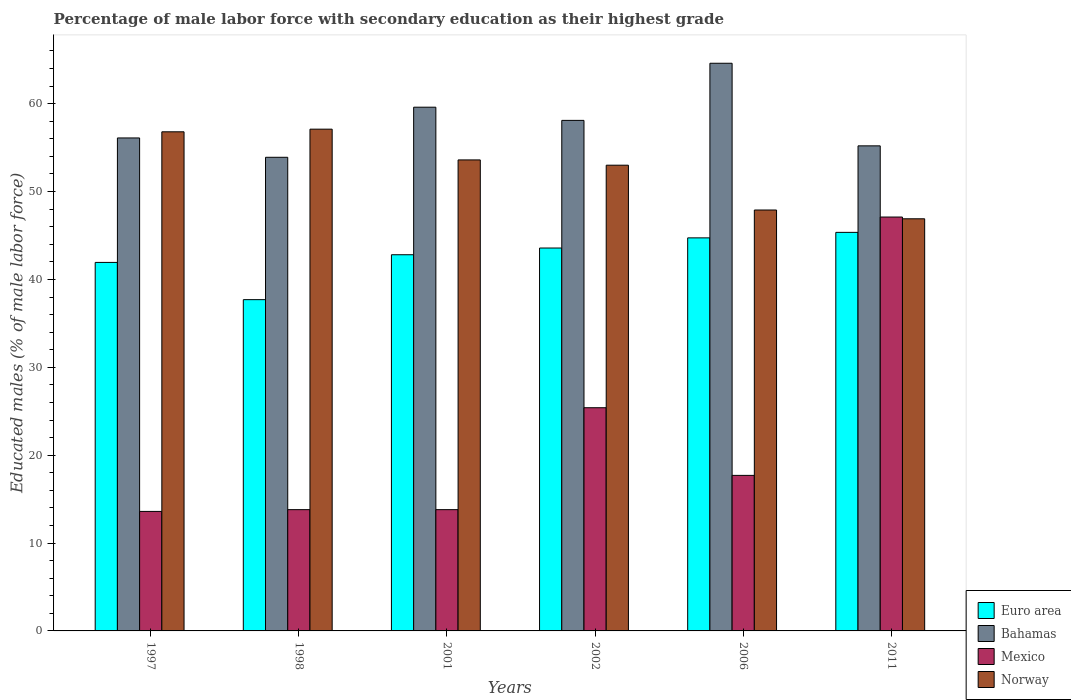How many groups of bars are there?
Ensure brevity in your answer.  6. Are the number of bars per tick equal to the number of legend labels?
Ensure brevity in your answer.  Yes. Are the number of bars on each tick of the X-axis equal?
Make the answer very short. Yes. How many bars are there on the 4th tick from the left?
Your response must be concise. 4. How many bars are there on the 3rd tick from the right?
Keep it short and to the point. 4. In how many cases, is the number of bars for a given year not equal to the number of legend labels?
Offer a very short reply. 0. What is the percentage of male labor force with secondary education in Bahamas in 2006?
Give a very brief answer. 64.6. Across all years, what is the maximum percentage of male labor force with secondary education in Mexico?
Offer a terse response. 47.1. Across all years, what is the minimum percentage of male labor force with secondary education in Mexico?
Your answer should be very brief. 13.6. In which year was the percentage of male labor force with secondary education in Euro area minimum?
Offer a very short reply. 1998. What is the total percentage of male labor force with secondary education in Bahamas in the graph?
Keep it short and to the point. 347.5. What is the difference between the percentage of male labor force with secondary education in Mexico in 1997 and that in 1998?
Your answer should be very brief. -0.2. What is the difference between the percentage of male labor force with secondary education in Mexico in 2011 and the percentage of male labor force with secondary education in Euro area in 2006?
Make the answer very short. 2.37. What is the average percentage of male labor force with secondary education in Norway per year?
Your response must be concise. 52.55. In the year 1997, what is the difference between the percentage of male labor force with secondary education in Norway and percentage of male labor force with secondary education in Mexico?
Offer a very short reply. 43.2. In how many years, is the percentage of male labor force with secondary education in Mexico greater than 38 %?
Provide a short and direct response. 1. What is the ratio of the percentage of male labor force with secondary education in Bahamas in 1997 to that in 2011?
Provide a succinct answer. 1.02. Is the difference between the percentage of male labor force with secondary education in Norway in 1998 and 2011 greater than the difference between the percentage of male labor force with secondary education in Mexico in 1998 and 2011?
Your response must be concise. Yes. What is the difference between the highest and the second highest percentage of male labor force with secondary education in Mexico?
Offer a terse response. 21.7. What is the difference between the highest and the lowest percentage of male labor force with secondary education in Bahamas?
Your response must be concise. 10.7. In how many years, is the percentage of male labor force with secondary education in Mexico greater than the average percentage of male labor force with secondary education in Mexico taken over all years?
Your answer should be compact. 2. Is it the case that in every year, the sum of the percentage of male labor force with secondary education in Euro area and percentage of male labor force with secondary education in Norway is greater than the sum of percentage of male labor force with secondary education in Mexico and percentage of male labor force with secondary education in Bahamas?
Make the answer very short. Yes. What does the 1st bar from the right in 1997 represents?
Offer a terse response. Norway. Is it the case that in every year, the sum of the percentage of male labor force with secondary education in Norway and percentage of male labor force with secondary education in Mexico is greater than the percentage of male labor force with secondary education in Bahamas?
Make the answer very short. Yes. How many bars are there?
Make the answer very short. 24. How many years are there in the graph?
Give a very brief answer. 6. Does the graph contain any zero values?
Provide a short and direct response. No. What is the title of the graph?
Keep it short and to the point. Percentage of male labor force with secondary education as their highest grade. Does "El Salvador" appear as one of the legend labels in the graph?
Your answer should be very brief. No. What is the label or title of the X-axis?
Offer a very short reply. Years. What is the label or title of the Y-axis?
Your answer should be very brief. Educated males (% of male labor force). What is the Educated males (% of male labor force) of Euro area in 1997?
Keep it short and to the point. 41.94. What is the Educated males (% of male labor force) of Bahamas in 1997?
Keep it short and to the point. 56.1. What is the Educated males (% of male labor force) of Mexico in 1997?
Give a very brief answer. 13.6. What is the Educated males (% of male labor force) in Norway in 1997?
Ensure brevity in your answer.  56.8. What is the Educated males (% of male labor force) in Euro area in 1998?
Ensure brevity in your answer.  37.7. What is the Educated males (% of male labor force) of Bahamas in 1998?
Give a very brief answer. 53.9. What is the Educated males (% of male labor force) in Mexico in 1998?
Ensure brevity in your answer.  13.8. What is the Educated males (% of male labor force) of Norway in 1998?
Your answer should be compact. 57.1. What is the Educated males (% of male labor force) in Euro area in 2001?
Provide a short and direct response. 42.81. What is the Educated males (% of male labor force) in Bahamas in 2001?
Make the answer very short. 59.6. What is the Educated males (% of male labor force) of Mexico in 2001?
Your answer should be very brief. 13.8. What is the Educated males (% of male labor force) in Norway in 2001?
Give a very brief answer. 53.6. What is the Educated males (% of male labor force) in Euro area in 2002?
Make the answer very short. 43.57. What is the Educated males (% of male labor force) in Bahamas in 2002?
Your answer should be very brief. 58.1. What is the Educated males (% of male labor force) in Mexico in 2002?
Make the answer very short. 25.4. What is the Educated males (% of male labor force) in Norway in 2002?
Make the answer very short. 53. What is the Educated males (% of male labor force) of Euro area in 2006?
Keep it short and to the point. 44.73. What is the Educated males (% of male labor force) of Bahamas in 2006?
Provide a succinct answer. 64.6. What is the Educated males (% of male labor force) of Mexico in 2006?
Provide a short and direct response. 17.7. What is the Educated males (% of male labor force) of Norway in 2006?
Make the answer very short. 47.9. What is the Educated males (% of male labor force) in Euro area in 2011?
Your answer should be very brief. 45.35. What is the Educated males (% of male labor force) of Bahamas in 2011?
Provide a succinct answer. 55.2. What is the Educated males (% of male labor force) of Mexico in 2011?
Make the answer very short. 47.1. What is the Educated males (% of male labor force) of Norway in 2011?
Keep it short and to the point. 46.9. Across all years, what is the maximum Educated males (% of male labor force) of Euro area?
Ensure brevity in your answer.  45.35. Across all years, what is the maximum Educated males (% of male labor force) in Bahamas?
Give a very brief answer. 64.6. Across all years, what is the maximum Educated males (% of male labor force) in Mexico?
Your answer should be very brief. 47.1. Across all years, what is the maximum Educated males (% of male labor force) of Norway?
Offer a very short reply. 57.1. Across all years, what is the minimum Educated males (% of male labor force) of Euro area?
Your answer should be compact. 37.7. Across all years, what is the minimum Educated males (% of male labor force) of Bahamas?
Make the answer very short. 53.9. Across all years, what is the minimum Educated males (% of male labor force) of Mexico?
Your answer should be compact. 13.6. Across all years, what is the minimum Educated males (% of male labor force) in Norway?
Your response must be concise. 46.9. What is the total Educated males (% of male labor force) in Euro area in the graph?
Make the answer very short. 256.1. What is the total Educated males (% of male labor force) in Bahamas in the graph?
Make the answer very short. 347.5. What is the total Educated males (% of male labor force) in Mexico in the graph?
Your response must be concise. 131.4. What is the total Educated males (% of male labor force) of Norway in the graph?
Make the answer very short. 315.3. What is the difference between the Educated males (% of male labor force) in Euro area in 1997 and that in 1998?
Provide a succinct answer. 4.24. What is the difference between the Educated males (% of male labor force) in Bahamas in 1997 and that in 1998?
Provide a succinct answer. 2.2. What is the difference between the Educated males (% of male labor force) in Norway in 1997 and that in 1998?
Make the answer very short. -0.3. What is the difference between the Educated males (% of male labor force) in Euro area in 1997 and that in 2001?
Your answer should be compact. -0.87. What is the difference between the Educated males (% of male labor force) of Euro area in 1997 and that in 2002?
Offer a terse response. -1.64. What is the difference between the Educated males (% of male labor force) in Euro area in 1997 and that in 2006?
Offer a terse response. -2.79. What is the difference between the Educated males (% of male labor force) of Bahamas in 1997 and that in 2006?
Provide a succinct answer. -8.5. What is the difference between the Educated males (% of male labor force) of Norway in 1997 and that in 2006?
Give a very brief answer. 8.9. What is the difference between the Educated males (% of male labor force) of Euro area in 1997 and that in 2011?
Provide a succinct answer. -3.42. What is the difference between the Educated males (% of male labor force) in Bahamas in 1997 and that in 2011?
Provide a succinct answer. 0.9. What is the difference between the Educated males (% of male labor force) of Mexico in 1997 and that in 2011?
Your answer should be very brief. -33.5. What is the difference between the Educated males (% of male labor force) in Euro area in 1998 and that in 2001?
Your answer should be very brief. -5.11. What is the difference between the Educated males (% of male labor force) in Euro area in 1998 and that in 2002?
Make the answer very short. -5.88. What is the difference between the Educated males (% of male labor force) in Mexico in 1998 and that in 2002?
Offer a terse response. -11.6. What is the difference between the Educated males (% of male labor force) in Norway in 1998 and that in 2002?
Offer a terse response. 4.1. What is the difference between the Educated males (% of male labor force) of Euro area in 1998 and that in 2006?
Offer a terse response. -7.03. What is the difference between the Educated males (% of male labor force) of Norway in 1998 and that in 2006?
Make the answer very short. 9.2. What is the difference between the Educated males (% of male labor force) of Euro area in 1998 and that in 2011?
Provide a succinct answer. -7.66. What is the difference between the Educated males (% of male labor force) in Bahamas in 1998 and that in 2011?
Provide a succinct answer. -1.3. What is the difference between the Educated males (% of male labor force) of Mexico in 1998 and that in 2011?
Your answer should be compact. -33.3. What is the difference between the Educated males (% of male labor force) in Euro area in 2001 and that in 2002?
Your response must be concise. -0.76. What is the difference between the Educated males (% of male labor force) in Bahamas in 2001 and that in 2002?
Provide a short and direct response. 1.5. What is the difference between the Educated males (% of male labor force) in Norway in 2001 and that in 2002?
Give a very brief answer. 0.6. What is the difference between the Educated males (% of male labor force) of Euro area in 2001 and that in 2006?
Offer a very short reply. -1.92. What is the difference between the Educated males (% of male labor force) in Mexico in 2001 and that in 2006?
Provide a succinct answer. -3.9. What is the difference between the Educated males (% of male labor force) of Norway in 2001 and that in 2006?
Offer a very short reply. 5.7. What is the difference between the Educated males (% of male labor force) of Euro area in 2001 and that in 2011?
Offer a terse response. -2.55. What is the difference between the Educated males (% of male labor force) in Mexico in 2001 and that in 2011?
Your response must be concise. -33.3. What is the difference between the Educated males (% of male labor force) in Euro area in 2002 and that in 2006?
Provide a succinct answer. -1.15. What is the difference between the Educated males (% of male labor force) of Bahamas in 2002 and that in 2006?
Provide a short and direct response. -6.5. What is the difference between the Educated males (% of male labor force) of Mexico in 2002 and that in 2006?
Ensure brevity in your answer.  7.7. What is the difference between the Educated males (% of male labor force) of Norway in 2002 and that in 2006?
Provide a succinct answer. 5.1. What is the difference between the Educated males (% of male labor force) in Euro area in 2002 and that in 2011?
Provide a succinct answer. -1.78. What is the difference between the Educated males (% of male labor force) of Mexico in 2002 and that in 2011?
Ensure brevity in your answer.  -21.7. What is the difference between the Educated males (% of male labor force) of Norway in 2002 and that in 2011?
Give a very brief answer. 6.1. What is the difference between the Educated males (% of male labor force) of Euro area in 2006 and that in 2011?
Offer a very short reply. -0.63. What is the difference between the Educated males (% of male labor force) in Mexico in 2006 and that in 2011?
Keep it short and to the point. -29.4. What is the difference between the Educated males (% of male labor force) in Euro area in 1997 and the Educated males (% of male labor force) in Bahamas in 1998?
Make the answer very short. -11.96. What is the difference between the Educated males (% of male labor force) in Euro area in 1997 and the Educated males (% of male labor force) in Mexico in 1998?
Offer a terse response. 28.14. What is the difference between the Educated males (% of male labor force) of Euro area in 1997 and the Educated males (% of male labor force) of Norway in 1998?
Make the answer very short. -15.16. What is the difference between the Educated males (% of male labor force) in Bahamas in 1997 and the Educated males (% of male labor force) in Mexico in 1998?
Make the answer very short. 42.3. What is the difference between the Educated males (% of male labor force) in Bahamas in 1997 and the Educated males (% of male labor force) in Norway in 1998?
Keep it short and to the point. -1. What is the difference between the Educated males (% of male labor force) of Mexico in 1997 and the Educated males (% of male labor force) of Norway in 1998?
Ensure brevity in your answer.  -43.5. What is the difference between the Educated males (% of male labor force) in Euro area in 1997 and the Educated males (% of male labor force) in Bahamas in 2001?
Your answer should be compact. -17.66. What is the difference between the Educated males (% of male labor force) in Euro area in 1997 and the Educated males (% of male labor force) in Mexico in 2001?
Keep it short and to the point. 28.14. What is the difference between the Educated males (% of male labor force) in Euro area in 1997 and the Educated males (% of male labor force) in Norway in 2001?
Provide a short and direct response. -11.66. What is the difference between the Educated males (% of male labor force) in Bahamas in 1997 and the Educated males (% of male labor force) in Mexico in 2001?
Your answer should be very brief. 42.3. What is the difference between the Educated males (% of male labor force) in Bahamas in 1997 and the Educated males (% of male labor force) in Norway in 2001?
Make the answer very short. 2.5. What is the difference between the Educated males (% of male labor force) in Euro area in 1997 and the Educated males (% of male labor force) in Bahamas in 2002?
Your response must be concise. -16.16. What is the difference between the Educated males (% of male labor force) in Euro area in 1997 and the Educated males (% of male labor force) in Mexico in 2002?
Your answer should be compact. 16.54. What is the difference between the Educated males (% of male labor force) of Euro area in 1997 and the Educated males (% of male labor force) of Norway in 2002?
Offer a very short reply. -11.06. What is the difference between the Educated males (% of male labor force) of Bahamas in 1997 and the Educated males (% of male labor force) of Mexico in 2002?
Make the answer very short. 30.7. What is the difference between the Educated males (% of male labor force) of Mexico in 1997 and the Educated males (% of male labor force) of Norway in 2002?
Offer a terse response. -39.4. What is the difference between the Educated males (% of male labor force) of Euro area in 1997 and the Educated males (% of male labor force) of Bahamas in 2006?
Offer a very short reply. -22.66. What is the difference between the Educated males (% of male labor force) in Euro area in 1997 and the Educated males (% of male labor force) in Mexico in 2006?
Your response must be concise. 24.24. What is the difference between the Educated males (% of male labor force) in Euro area in 1997 and the Educated males (% of male labor force) in Norway in 2006?
Your answer should be very brief. -5.96. What is the difference between the Educated males (% of male labor force) in Bahamas in 1997 and the Educated males (% of male labor force) in Mexico in 2006?
Your answer should be compact. 38.4. What is the difference between the Educated males (% of male labor force) of Bahamas in 1997 and the Educated males (% of male labor force) of Norway in 2006?
Provide a short and direct response. 8.2. What is the difference between the Educated males (% of male labor force) in Mexico in 1997 and the Educated males (% of male labor force) in Norway in 2006?
Your answer should be compact. -34.3. What is the difference between the Educated males (% of male labor force) in Euro area in 1997 and the Educated males (% of male labor force) in Bahamas in 2011?
Your answer should be compact. -13.26. What is the difference between the Educated males (% of male labor force) of Euro area in 1997 and the Educated males (% of male labor force) of Mexico in 2011?
Make the answer very short. -5.16. What is the difference between the Educated males (% of male labor force) of Euro area in 1997 and the Educated males (% of male labor force) of Norway in 2011?
Your answer should be compact. -4.96. What is the difference between the Educated males (% of male labor force) in Mexico in 1997 and the Educated males (% of male labor force) in Norway in 2011?
Give a very brief answer. -33.3. What is the difference between the Educated males (% of male labor force) in Euro area in 1998 and the Educated males (% of male labor force) in Bahamas in 2001?
Keep it short and to the point. -21.9. What is the difference between the Educated males (% of male labor force) of Euro area in 1998 and the Educated males (% of male labor force) of Mexico in 2001?
Your response must be concise. 23.9. What is the difference between the Educated males (% of male labor force) in Euro area in 1998 and the Educated males (% of male labor force) in Norway in 2001?
Give a very brief answer. -15.9. What is the difference between the Educated males (% of male labor force) in Bahamas in 1998 and the Educated males (% of male labor force) in Mexico in 2001?
Your response must be concise. 40.1. What is the difference between the Educated males (% of male labor force) of Bahamas in 1998 and the Educated males (% of male labor force) of Norway in 2001?
Your response must be concise. 0.3. What is the difference between the Educated males (% of male labor force) in Mexico in 1998 and the Educated males (% of male labor force) in Norway in 2001?
Provide a short and direct response. -39.8. What is the difference between the Educated males (% of male labor force) of Euro area in 1998 and the Educated males (% of male labor force) of Bahamas in 2002?
Provide a succinct answer. -20.4. What is the difference between the Educated males (% of male labor force) in Euro area in 1998 and the Educated males (% of male labor force) in Mexico in 2002?
Keep it short and to the point. 12.3. What is the difference between the Educated males (% of male labor force) in Euro area in 1998 and the Educated males (% of male labor force) in Norway in 2002?
Provide a short and direct response. -15.3. What is the difference between the Educated males (% of male labor force) of Bahamas in 1998 and the Educated males (% of male labor force) of Mexico in 2002?
Offer a very short reply. 28.5. What is the difference between the Educated males (% of male labor force) in Mexico in 1998 and the Educated males (% of male labor force) in Norway in 2002?
Provide a succinct answer. -39.2. What is the difference between the Educated males (% of male labor force) of Euro area in 1998 and the Educated males (% of male labor force) of Bahamas in 2006?
Provide a succinct answer. -26.9. What is the difference between the Educated males (% of male labor force) in Euro area in 1998 and the Educated males (% of male labor force) in Mexico in 2006?
Your answer should be compact. 20. What is the difference between the Educated males (% of male labor force) of Euro area in 1998 and the Educated males (% of male labor force) of Norway in 2006?
Keep it short and to the point. -10.2. What is the difference between the Educated males (% of male labor force) of Bahamas in 1998 and the Educated males (% of male labor force) of Mexico in 2006?
Your response must be concise. 36.2. What is the difference between the Educated males (% of male labor force) of Mexico in 1998 and the Educated males (% of male labor force) of Norway in 2006?
Your response must be concise. -34.1. What is the difference between the Educated males (% of male labor force) in Euro area in 1998 and the Educated males (% of male labor force) in Bahamas in 2011?
Give a very brief answer. -17.5. What is the difference between the Educated males (% of male labor force) of Euro area in 1998 and the Educated males (% of male labor force) of Mexico in 2011?
Keep it short and to the point. -9.4. What is the difference between the Educated males (% of male labor force) of Euro area in 1998 and the Educated males (% of male labor force) of Norway in 2011?
Provide a short and direct response. -9.2. What is the difference between the Educated males (% of male labor force) of Bahamas in 1998 and the Educated males (% of male labor force) of Mexico in 2011?
Your answer should be compact. 6.8. What is the difference between the Educated males (% of male labor force) in Bahamas in 1998 and the Educated males (% of male labor force) in Norway in 2011?
Your answer should be compact. 7. What is the difference between the Educated males (% of male labor force) in Mexico in 1998 and the Educated males (% of male labor force) in Norway in 2011?
Give a very brief answer. -33.1. What is the difference between the Educated males (% of male labor force) in Euro area in 2001 and the Educated males (% of male labor force) in Bahamas in 2002?
Provide a succinct answer. -15.29. What is the difference between the Educated males (% of male labor force) in Euro area in 2001 and the Educated males (% of male labor force) in Mexico in 2002?
Offer a very short reply. 17.41. What is the difference between the Educated males (% of male labor force) in Euro area in 2001 and the Educated males (% of male labor force) in Norway in 2002?
Offer a terse response. -10.19. What is the difference between the Educated males (% of male labor force) in Bahamas in 2001 and the Educated males (% of male labor force) in Mexico in 2002?
Provide a short and direct response. 34.2. What is the difference between the Educated males (% of male labor force) of Mexico in 2001 and the Educated males (% of male labor force) of Norway in 2002?
Offer a terse response. -39.2. What is the difference between the Educated males (% of male labor force) of Euro area in 2001 and the Educated males (% of male labor force) of Bahamas in 2006?
Offer a terse response. -21.79. What is the difference between the Educated males (% of male labor force) in Euro area in 2001 and the Educated males (% of male labor force) in Mexico in 2006?
Keep it short and to the point. 25.11. What is the difference between the Educated males (% of male labor force) in Euro area in 2001 and the Educated males (% of male labor force) in Norway in 2006?
Your answer should be very brief. -5.09. What is the difference between the Educated males (% of male labor force) of Bahamas in 2001 and the Educated males (% of male labor force) of Mexico in 2006?
Ensure brevity in your answer.  41.9. What is the difference between the Educated males (% of male labor force) in Mexico in 2001 and the Educated males (% of male labor force) in Norway in 2006?
Offer a terse response. -34.1. What is the difference between the Educated males (% of male labor force) in Euro area in 2001 and the Educated males (% of male labor force) in Bahamas in 2011?
Provide a succinct answer. -12.39. What is the difference between the Educated males (% of male labor force) in Euro area in 2001 and the Educated males (% of male labor force) in Mexico in 2011?
Your answer should be very brief. -4.29. What is the difference between the Educated males (% of male labor force) in Euro area in 2001 and the Educated males (% of male labor force) in Norway in 2011?
Offer a very short reply. -4.09. What is the difference between the Educated males (% of male labor force) of Bahamas in 2001 and the Educated males (% of male labor force) of Mexico in 2011?
Your answer should be very brief. 12.5. What is the difference between the Educated males (% of male labor force) of Bahamas in 2001 and the Educated males (% of male labor force) of Norway in 2011?
Keep it short and to the point. 12.7. What is the difference between the Educated males (% of male labor force) in Mexico in 2001 and the Educated males (% of male labor force) in Norway in 2011?
Give a very brief answer. -33.1. What is the difference between the Educated males (% of male labor force) of Euro area in 2002 and the Educated males (% of male labor force) of Bahamas in 2006?
Your answer should be very brief. -21.03. What is the difference between the Educated males (% of male labor force) of Euro area in 2002 and the Educated males (% of male labor force) of Mexico in 2006?
Your response must be concise. 25.87. What is the difference between the Educated males (% of male labor force) in Euro area in 2002 and the Educated males (% of male labor force) in Norway in 2006?
Make the answer very short. -4.33. What is the difference between the Educated males (% of male labor force) of Bahamas in 2002 and the Educated males (% of male labor force) of Mexico in 2006?
Offer a terse response. 40.4. What is the difference between the Educated males (% of male labor force) of Mexico in 2002 and the Educated males (% of male labor force) of Norway in 2006?
Keep it short and to the point. -22.5. What is the difference between the Educated males (% of male labor force) in Euro area in 2002 and the Educated males (% of male labor force) in Bahamas in 2011?
Offer a very short reply. -11.63. What is the difference between the Educated males (% of male labor force) in Euro area in 2002 and the Educated males (% of male labor force) in Mexico in 2011?
Make the answer very short. -3.53. What is the difference between the Educated males (% of male labor force) in Euro area in 2002 and the Educated males (% of male labor force) in Norway in 2011?
Offer a very short reply. -3.33. What is the difference between the Educated males (% of male labor force) of Bahamas in 2002 and the Educated males (% of male labor force) of Mexico in 2011?
Provide a succinct answer. 11. What is the difference between the Educated males (% of male labor force) of Mexico in 2002 and the Educated males (% of male labor force) of Norway in 2011?
Ensure brevity in your answer.  -21.5. What is the difference between the Educated males (% of male labor force) of Euro area in 2006 and the Educated males (% of male labor force) of Bahamas in 2011?
Provide a succinct answer. -10.47. What is the difference between the Educated males (% of male labor force) in Euro area in 2006 and the Educated males (% of male labor force) in Mexico in 2011?
Ensure brevity in your answer.  -2.37. What is the difference between the Educated males (% of male labor force) in Euro area in 2006 and the Educated males (% of male labor force) in Norway in 2011?
Your answer should be very brief. -2.17. What is the difference between the Educated males (% of male labor force) in Bahamas in 2006 and the Educated males (% of male labor force) in Mexico in 2011?
Keep it short and to the point. 17.5. What is the difference between the Educated males (% of male labor force) of Bahamas in 2006 and the Educated males (% of male labor force) of Norway in 2011?
Provide a succinct answer. 17.7. What is the difference between the Educated males (% of male labor force) of Mexico in 2006 and the Educated males (% of male labor force) of Norway in 2011?
Offer a very short reply. -29.2. What is the average Educated males (% of male labor force) of Euro area per year?
Offer a very short reply. 42.68. What is the average Educated males (% of male labor force) of Bahamas per year?
Provide a succinct answer. 57.92. What is the average Educated males (% of male labor force) of Mexico per year?
Offer a very short reply. 21.9. What is the average Educated males (% of male labor force) of Norway per year?
Your answer should be compact. 52.55. In the year 1997, what is the difference between the Educated males (% of male labor force) of Euro area and Educated males (% of male labor force) of Bahamas?
Provide a short and direct response. -14.16. In the year 1997, what is the difference between the Educated males (% of male labor force) in Euro area and Educated males (% of male labor force) in Mexico?
Keep it short and to the point. 28.34. In the year 1997, what is the difference between the Educated males (% of male labor force) in Euro area and Educated males (% of male labor force) in Norway?
Your response must be concise. -14.86. In the year 1997, what is the difference between the Educated males (% of male labor force) of Bahamas and Educated males (% of male labor force) of Mexico?
Offer a very short reply. 42.5. In the year 1997, what is the difference between the Educated males (% of male labor force) in Mexico and Educated males (% of male labor force) in Norway?
Your answer should be compact. -43.2. In the year 1998, what is the difference between the Educated males (% of male labor force) of Euro area and Educated males (% of male labor force) of Bahamas?
Your response must be concise. -16.2. In the year 1998, what is the difference between the Educated males (% of male labor force) in Euro area and Educated males (% of male labor force) in Mexico?
Your response must be concise. 23.9. In the year 1998, what is the difference between the Educated males (% of male labor force) in Euro area and Educated males (% of male labor force) in Norway?
Offer a very short reply. -19.4. In the year 1998, what is the difference between the Educated males (% of male labor force) in Bahamas and Educated males (% of male labor force) in Mexico?
Offer a very short reply. 40.1. In the year 1998, what is the difference between the Educated males (% of male labor force) in Mexico and Educated males (% of male labor force) in Norway?
Your response must be concise. -43.3. In the year 2001, what is the difference between the Educated males (% of male labor force) in Euro area and Educated males (% of male labor force) in Bahamas?
Your answer should be compact. -16.79. In the year 2001, what is the difference between the Educated males (% of male labor force) of Euro area and Educated males (% of male labor force) of Mexico?
Make the answer very short. 29.01. In the year 2001, what is the difference between the Educated males (% of male labor force) in Euro area and Educated males (% of male labor force) in Norway?
Make the answer very short. -10.79. In the year 2001, what is the difference between the Educated males (% of male labor force) of Bahamas and Educated males (% of male labor force) of Mexico?
Offer a terse response. 45.8. In the year 2001, what is the difference between the Educated males (% of male labor force) in Mexico and Educated males (% of male labor force) in Norway?
Make the answer very short. -39.8. In the year 2002, what is the difference between the Educated males (% of male labor force) in Euro area and Educated males (% of male labor force) in Bahamas?
Ensure brevity in your answer.  -14.53. In the year 2002, what is the difference between the Educated males (% of male labor force) in Euro area and Educated males (% of male labor force) in Mexico?
Provide a short and direct response. 18.17. In the year 2002, what is the difference between the Educated males (% of male labor force) in Euro area and Educated males (% of male labor force) in Norway?
Provide a succinct answer. -9.43. In the year 2002, what is the difference between the Educated males (% of male labor force) in Bahamas and Educated males (% of male labor force) in Mexico?
Keep it short and to the point. 32.7. In the year 2002, what is the difference between the Educated males (% of male labor force) in Mexico and Educated males (% of male labor force) in Norway?
Ensure brevity in your answer.  -27.6. In the year 2006, what is the difference between the Educated males (% of male labor force) in Euro area and Educated males (% of male labor force) in Bahamas?
Provide a short and direct response. -19.87. In the year 2006, what is the difference between the Educated males (% of male labor force) in Euro area and Educated males (% of male labor force) in Mexico?
Offer a very short reply. 27.03. In the year 2006, what is the difference between the Educated males (% of male labor force) of Euro area and Educated males (% of male labor force) of Norway?
Your answer should be very brief. -3.17. In the year 2006, what is the difference between the Educated males (% of male labor force) in Bahamas and Educated males (% of male labor force) in Mexico?
Your response must be concise. 46.9. In the year 2006, what is the difference between the Educated males (% of male labor force) in Bahamas and Educated males (% of male labor force) in Norway?
Provide a succinct answer. 16.7. In the year 2006, what is the difference between the Educated males (% of male labor force) in Mexico and Educated males (% of male labor force) in Norway?
Give a very brief answer. -30.2. In the year 2011, what is the difference between the Educated males (% of male labor force) of Euro area and Educated males (% of male labor force) of Bahamas?
Provide a succinct answer. -9.85. In the year 2011, what is the difference between the Educated males (% of male labor force) in Euro area and Educated males (% of male labor force) in Mexico?
Ensure brevity in your answer.  -1.75. In the year 2011, what is the difference between the Educated males (% of male labor force) of Euro area and Educated males (% of male labor force) of Norway?
Offer a terse response. -1.55. In the year 2011, what is the difference between the Educated males (% of male labor force) in Bahamas and Educated males (% of male labor force) in Norway?
Provide a succinct answer. 8.3. In the year 2011, what is the difference between the Educated males (% of male labor force) of Mexico and Educated males (% of male labor force) of Norway?
Ensure brevity in your answer.  0.2. What is the ratio of the Educated males (% of male labor force) of Euro area in 1997 to that in 1998?
Your response must be concise. 1.11. What is the ratio of the Educated males (% of male labor force) of Bahamas in 1997 to that in 1998?
Your response must be concise. 1.04. What is the ratio of the Educated males (% of male labor force) of Mexico in 1997 to that in 1998?
Your response must be concise. 0.99. What is the ratio of the Educated males (% of male labor force) in Euro area in 1997 to that in 2001?
Offer a very short reply. 0.98. What is the ratio of the Educated males (% of male labor force) in Bahamas in 1997 to that in 2001?
Your answer should be very brief. 0.94. What is the ratio of the Educated males (% of male labor force) in Mexico in 1997 to that in 2001?
Provide a succinct answer. 0.99. What is the ratio of the Educated males (% of male labor force) in Norway in 1997 to that in 2001?
Offer a terse response. 1.06. What is the ratio of the Educated males (% of male labor force) in Euro area in 1997 to that in 2002?
Your answer should be very brief. 0.96. What is the ratio of the Educated males (% of male labor force) of Bahamas in 1997 to that in 2002?
Ensure brevity in your answer.  0.97. What is the ratio of the Educated males (% of male labor force) of Mexico in 1997 to that in 2002?
Your answer should be very brief. 0.54. What is the ratio of the Educated males (% of male labor force) in Norway in 1997 to that in 2002?
Provide a succinct answer. 1.07. What is the ratio of the Educated males (% of male labor force) in Bahamas in 1997 to that in 2006?
Your response must be concise. 0.87. What is the ratio of the Educated males (% of male labor force) in Mexico in 1997 to that in 2006?
Your answer should be very brief. 0.77. What is the ratio of the Educated males (% of male labor force) in Norway in 1997 to that in 2006?
Offer a very short reply. 1.19. What is the ratio of the Educated males (% of male labor force) in Euro area in 1997 to that in 2011?
Ensure brevity in your answer.  0.92. What is the ratio of the Educated males (% of male labor force) in Bahamas in 1997 to that in 2011?
Make the answer very short. 1.02. What is the ratio of the Educated males (% of male labor force) in Mexico in 1997 to that in 2011?
Your response must be concise. 0.29. What is the ratio of the Educated males (% of male labor force) of Norway in 1997 to that in 2011?
Ensure brevity in your answer.  1.21. What is the ratio of the Educated males (% of male labor force) of Euro area in 1998 to that in 2001?
Your response must be concise. 0.88. What is the ratio of the Educated males (% of male labor force) in Bahamas in 1998 to that in 2001?
Ensure brevity in your answer.  0.9. What is the ratio of the Educated males (% of male labor force) of Mexico in 1998 to that in 2001?
Your response must be concise. 1. What is the ratio of the Educated males (% of male labor force) of Norway in 1998 to that in 2001?
Give a very brief answer. 1.07. What is the ratio of the Educated males (% of male labor force) in Euro area in 1998 to that in 2002?
Provide a succinct answer. 0.87. What is the ratio of the Educated males (% of male labor force) in Bahamas in 1998 to that in 2002?
Provide a short and direct response. 0.93. What is the ratio of the Educated males (% of male labor force) of Mexico in 1998 to that in 2002?
Offer a very short reply. 0.54. What is the ratio of the Educated males (% of male labor force) of Norway in 1998 to that in 2002?
Offer a very short reply. 1.08. What is the ratio of the Educated males (% of male labor force) in Euro area in 1998 to that in 2006?
Provide a short and direct response. 0.84. What is the ratio of the Educated males (% of male labor force) of Bahamas in 1998 to that in 2006?
Your answer should be very brief. 0.83. What is the ratio of the Educated males (% of male labor force) of Mexico in 1998 to that in 2006?
Your response must be concise. 0.78. What is the ratio of the Educated males (% of male labor force) of Norway in 1998 to that in 2006?
Offer a very short reply. 1.19. What is the ratio of the Educated males (% of male labor force) of Euro area in 1998 to that in 2011?
Provide a succinct answer. 0.83. What is the ratio of the Educated males (% of male labor force) in Bahamas in 1998 to that in 2011?
Offer a very short reply. 0.98. What is the ratio of the Educated males (% of male labor force) in Mexico in 1998 to that in 2011?
Your answer should be compact. 0.29. What is the ratio of the Educated males (% of male labor force) in Norway in 1998 to that in 2011?
Offer a very short reply. 1.22. What is the ratio of the Educated males (% of male labor force) of Euro area in 2001 to that in 2002?
Offer a very short reply. 0.98. What is the ratio of the Educated males (% of male labor force) of Bahamas in 2001 to that in 2002?
Give a very brief answer. 1.03. What is the ratio of the Educated males (% of male labor force) in Mexico in 2001 to that in 2002?
Ensure brevity in your answer.  0.54. What is the ratio of the Educated males (% of male labor force) in Norway in 2001 to that in 2002?
Ensure brevity in your answer.  1.01. What is the ratio of the Educated males (% of male labor force) in Euro area in 2001 to that in 2006?
Keep it short and to the point. 0.96. What is the ratio of the Educated males (% of male labor force) in Bahamas in 2001 to that in 2006?
Provide a short and direct response. 0.92. What is the ratio of the Educated males (% of male labor force) in Mexico in 2001 to that in 2006?
Your response must be concise. 0.78. What is the ratio of the Educated males (% of male labor force) of Norway in 2001 to that in 2006?
Offer a terse response. 1.12. What is the ratio of the Educated males (% of male labor force) of Euro area in 2001 to that in 2011?
Ensure brevity in your answer.  0.94. What is the ratio of the Educated males (% of male labor force) in Bahamas in 2001 to that in 2011?
Offer a terse response. 1.08. What is the ratio of the Educated males (% of male labor force) of Mexico in 2001 to that in 2011?
Your answer should be very brief. 0.29. What is the ratio of the Educated males (% of male labor force) of Norway in 2001 to that in 2011?
Your answer should be compact. 1.14. What is the ratio of the Educated males (% of male labor force) in Euro area in 2002 to that in 2006?
Provide a succinct answer. 0.97. What is the ratio of the Educated males (% of male labor force) of Bahamas in 2002 to that in 2006?
Your answer should be compact. 0.9. What is the ratio of the Educated males (% of male labor force) in Mexico in 2002 to that in 2006?
Give a very brief answer. 1.44. What is the ratio of the Educated males (% of male labor force) in Norway in 2002 to that in 2006?
Ensure brevity in your answer.  1.11. What is the ratio of the Educated males (% of male labor force) of Euro area in 2002 to that in 2011?
Provide a succinct answer. 0.96. What is the ratio of the Educated males (% of male labor force) in Bahamas in 2002 to that in 2011?
Provide a short and direct response. 1.05. What is the ratio of the Educated males (% of male labor force) in Mexico in 2002 to that in 2011?
Your answer should be very brief. 0.54. What is the ratio of the Educated males (% of male labor force) in Norway in 2002 to that in 2011?
Give a very brief answer. 1.13. What is the ratio of the Educated males (% of male labor force) in Euro area in 2006 to that in 2011?
Offer a very short reply. 0.99. What is the ratio of the Educated males (% of male labor force) in Bahamas in 2006 to that in 2011?
Your answer should be compact. 1.17. What is the ratio of the Educated males (% of male labor force) in Mexico in 2006 to that in 2011?
Give a very brief answer. 0.38. What is the ratio of the Educated males (% of male labor force) in Norway in 2006 to that in 2011?
Make the answer very short. 1.02. What is the difference between the highest and the second highest Educated males (% of male labor force) of Euro area?
Your answer should be compact. 0.63. What is the difference between the highest and the second highest Educated males (% of male labor force) in Mexico?
Ensure brevity in your answer.  21.7. What is the difference between the highest and the lowest Educated males (% of male labor force) of Euro area?
Give a very brief answer. 7.66. What is the difference between the highest and the lowest Educated males (% of male labor force) of Bahamas?
Your response must be concise. 10.7. What is the difference between the highest and the lowest Educated males (% of male labor force) in Mexico?
Provide a succinct answer. 33.5. 